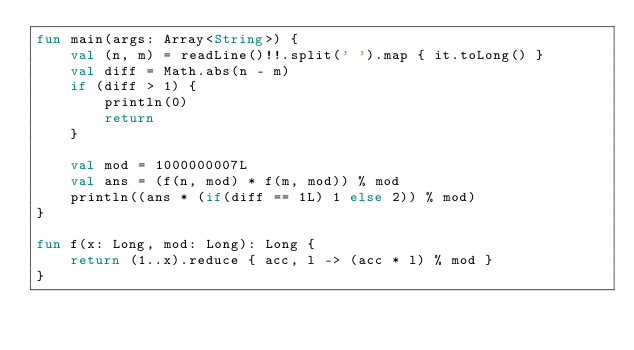Convert code to text. <code><loc_0><loc_0><loc_500><loc_500><_Kotlin_>fun main(args: Array<String>) {
    val (n, m) = readLine()!!.split(' ').map { it.toLong() }
    val diff = Math.abs(n - m)
    if (diff > 1) {
        println(0)
        return
    }

    val mod = 1000000007L
    val ans = (f(n, mod) * f(m, mod)) % mod
    println((ans * (if(diff == 1L) 1 else 2)) % mod)
}

fun f(x: Long, mod: Long): Long {
    return (1..x).reduce { acc, l -> (acc * l) % mod }
}
</code> 